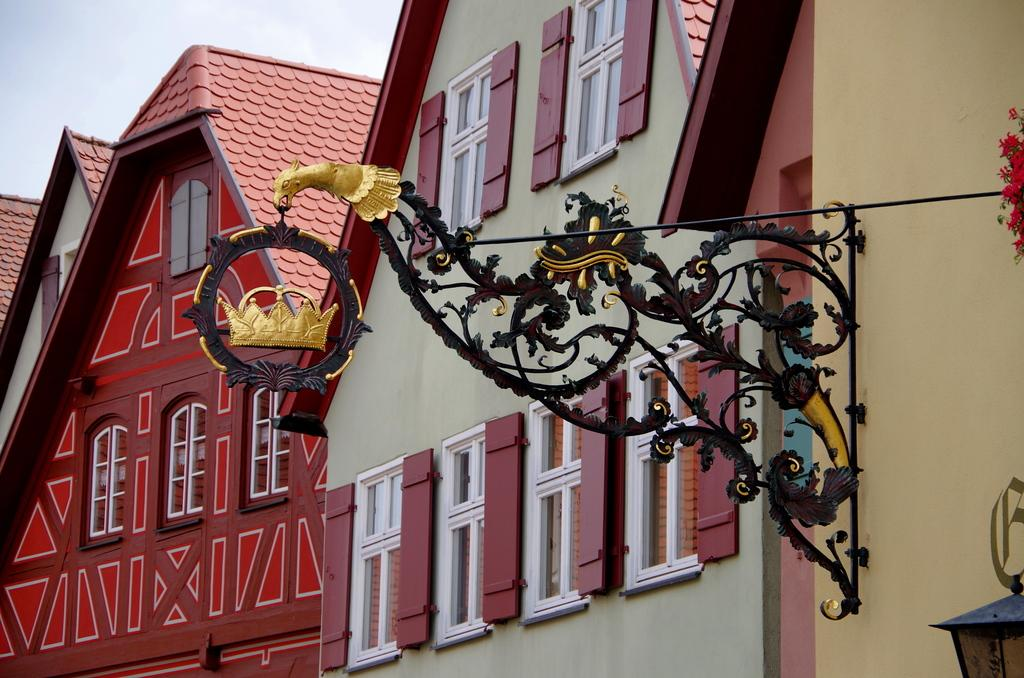What type of house is depicted in the image? There is a colorful house in the image. What can be seen on the wall of the house? There is a metal rod and red color flowers on the wall. What is visible in the background of the image? The sky is visible in the background of the image. What type of order is the judge issuing in the image? There is no judge or order present in the image; it features a colorful house with a metal rod and red color flowers on the wall. 